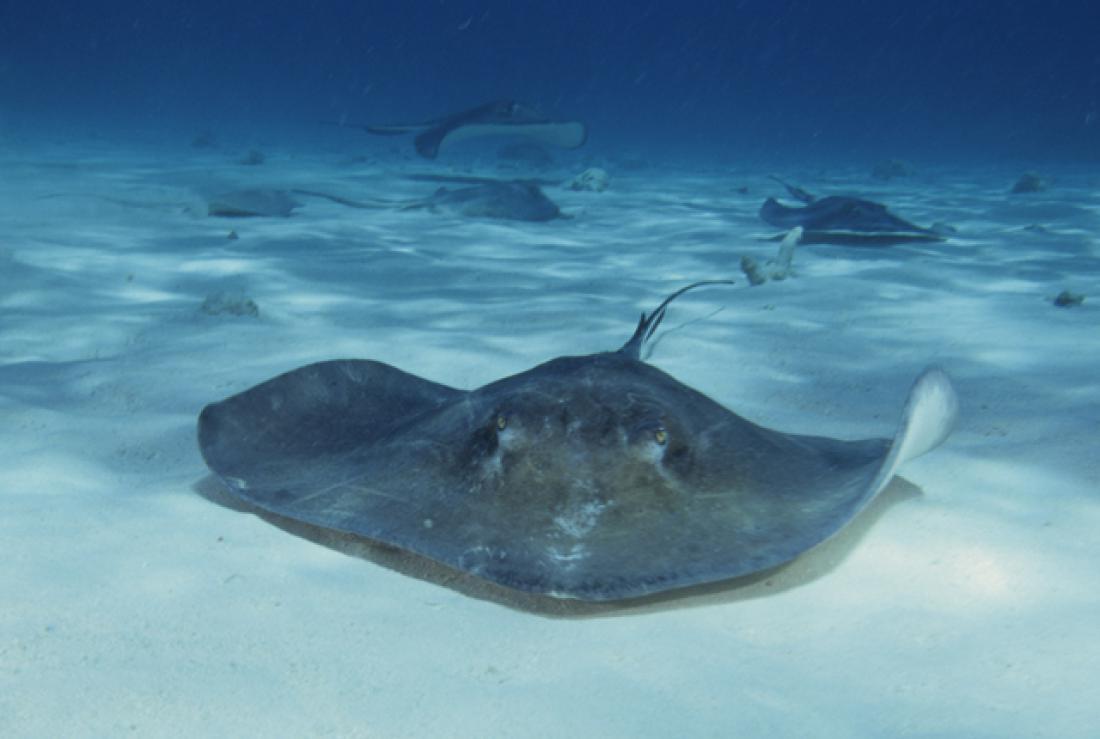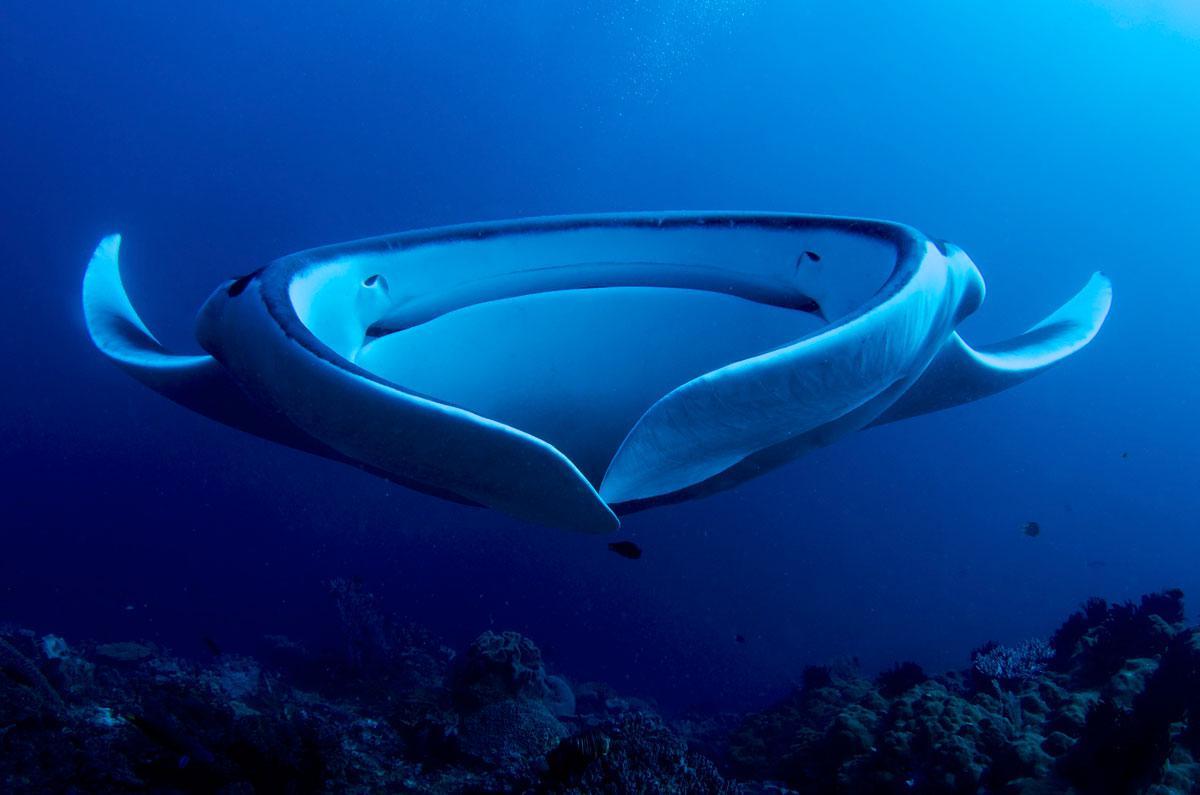The first image is the image on the left, the second image is the image on the right. For the images displayed, is the sentence "The animal in the image on the left is just above the seafloor." factually correct? Answer yes or no. Yes. 